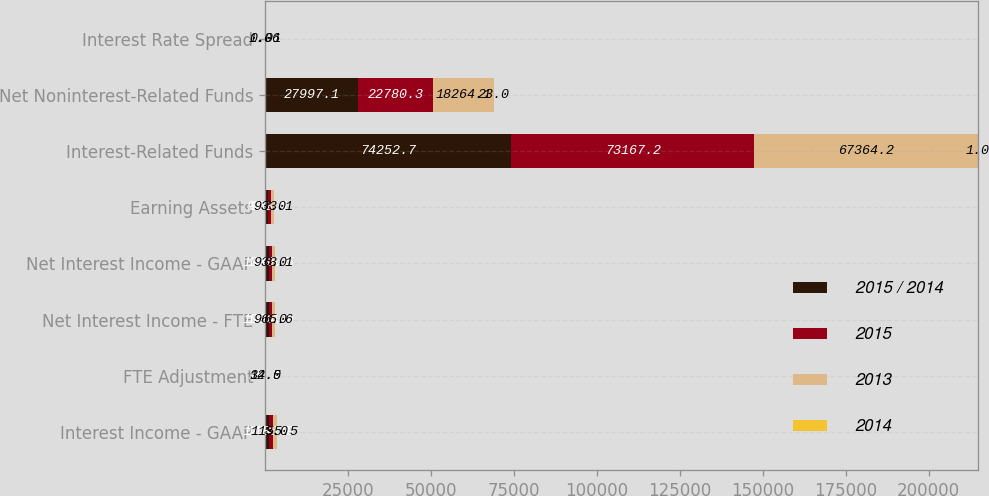<chart> <loc_0><loc_0><loc_500><loc_500><stacked_bar_chart><ecel><fcel>Interest Income - GAAP<fcel>FTE Adjustment<fcel>Net Interest Income - FTE<fcel>Net Interest Income - GAAP<fcel>Earning Assets<fcel>Interest-Related Funds<fcel>Net Noninterest-Related Funds<fcel>Interest Rate Spread<nl><fcel>2015 / 2014<fcel>1224<fcel>25.3<fcel>1095.4<fcel>1070.1<fcel>933.1<fcel>74252.7<fcel>27997.1<fcel>1.01<nl><fcel>2015<fcel>1186.9<fcel>29.4<fcel>1034.9<fcel>1005.5<fcel>933.1<fcel>73167.2<fcel>22780.3<fcel>1.02<nl><fcel>2013<fcel>1155.5<fcel>32.5<fcel>965.6<fcel>933.1<fcel>933.1<fcel>67364.2<fcel>18264.1<fcel>1.06<nl><fcel>2014<fcel>3<fcel>14<fcel>6<fcel>6<fcel>7<fcel>1<fcel>23<fcel>0.01<nl></chart> 